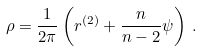Convert formula to latex. <formula><loc_0><loc_0><loc_500><loc_500>\rho = \frac { 1 } { 2 \pi } \left ( r ^ { ( 2 ) } + \frac { n } { n - 2 } \psi \right ) \, .</formula> 